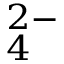Convert formula to latex. <formula><loc_0><loc_0><loc_500><loc_500>_ { 4 } ^ { 2 - }</formula> 